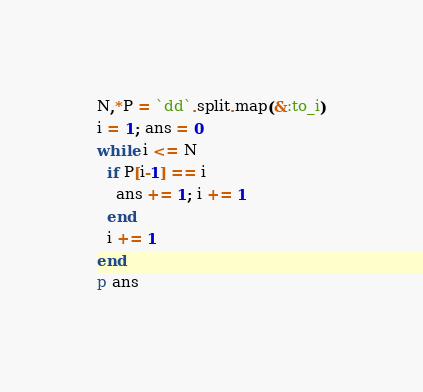<code> <loc_0><loc_0><loc_500><loc_500><_Ruby_>N,*P = `dd`.split.map(&:to_i)
i = 1; ans = 0
while i <= N
  if P[i-1] == i
    ans += 1; i += 1
  end
  i += 1
end
p ans
</code> 